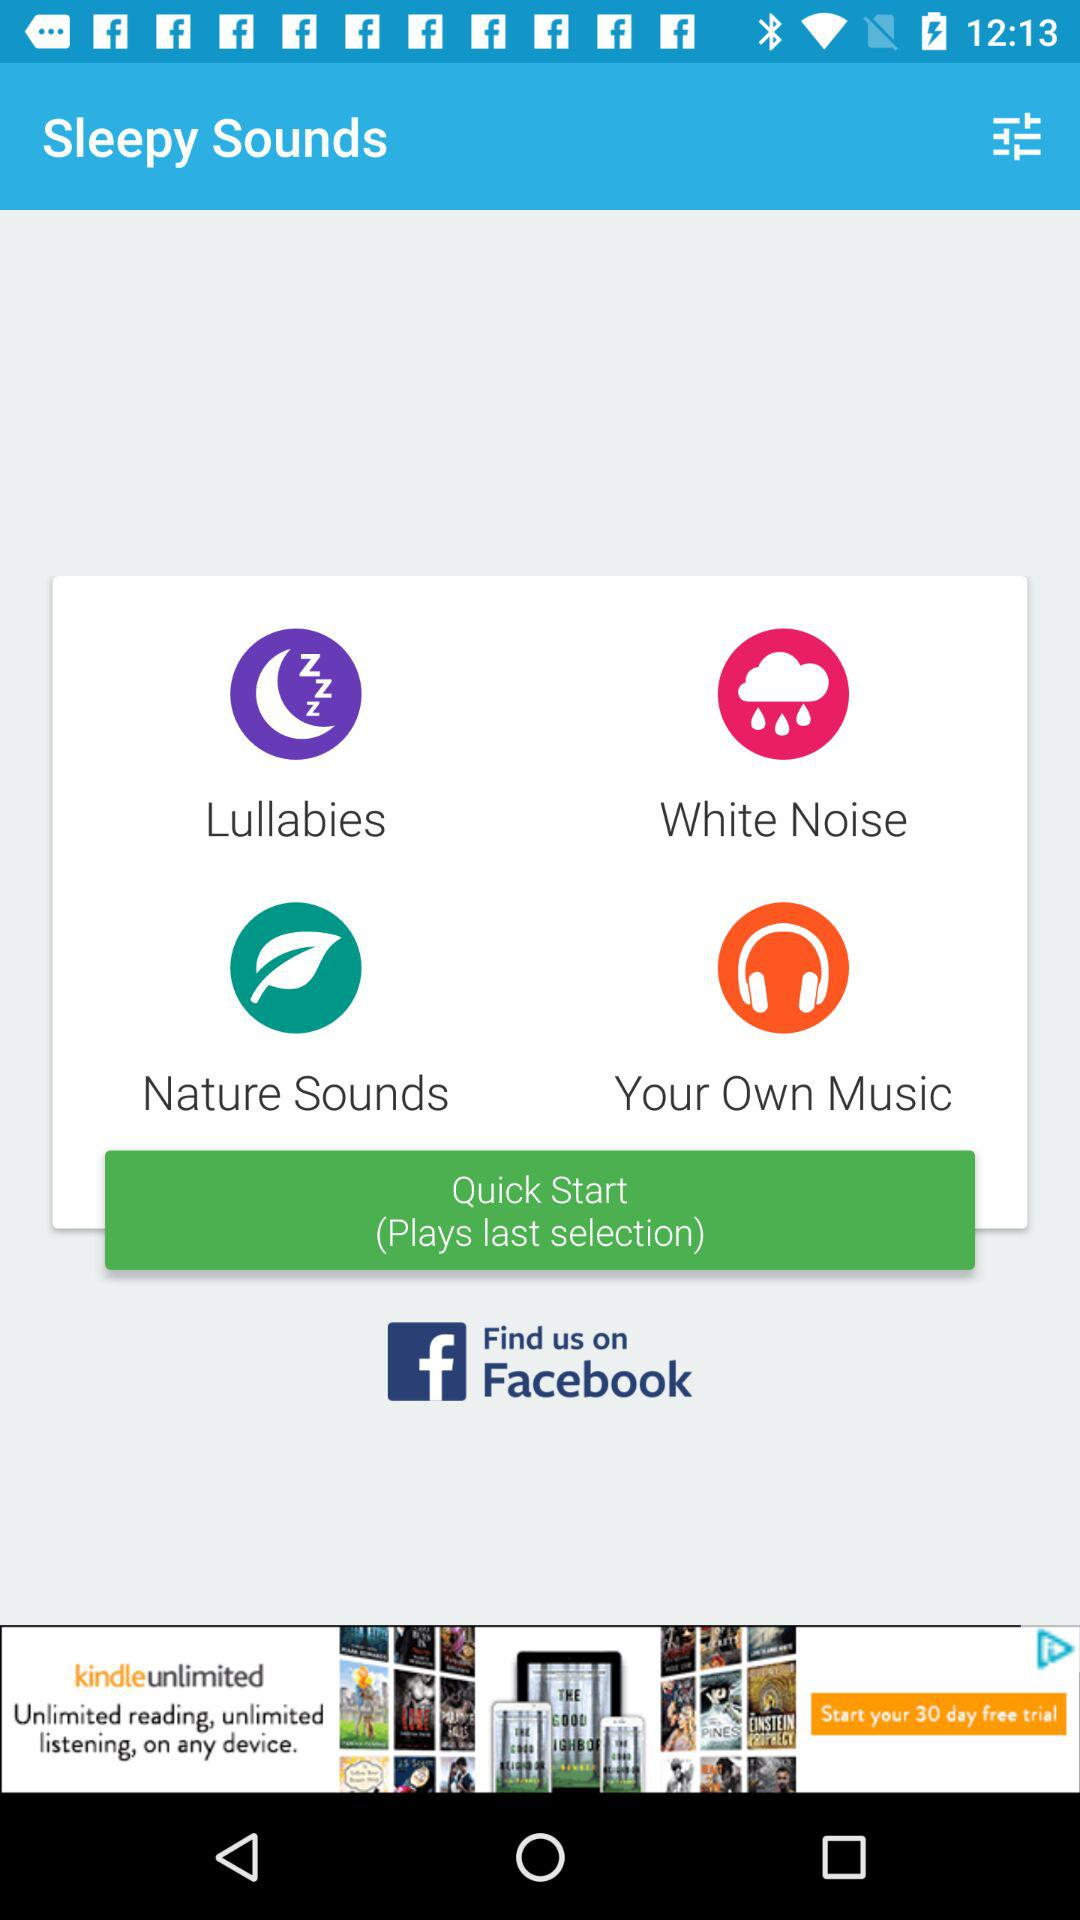What are the options in "Sleepy Sounds"? The options in "Sleepy Sounds" are "Lullabies", "White Noise", "Nature Sounds" and "Your Own Music". 